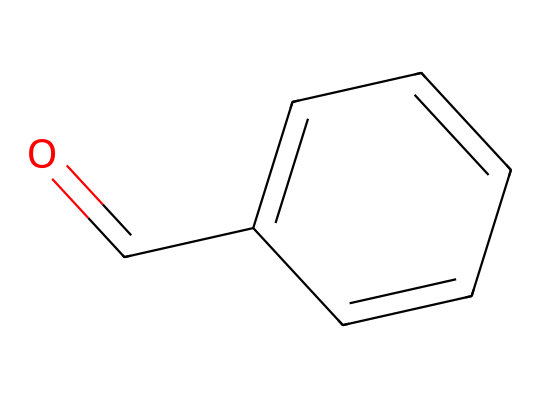What is the main functional group present in this chemical? The chemical structure includes a carbonyl group (C=O) attached to a carbon atom, indicating the presence of an aldehyde functional group in its structure.
Answer: aldehyde How many carbon atoms are in this compound? The visual representation shows a total of 7 carbon atoms, as indicated by the carbon chain and the benzene ring structure.
Answer: 7 What is the molecular formula derived from this structure? From the structure, we can count the atoms as follows: 7 carbon (C), 6 hydrogen (H), and 1 oxygen (O), which gives the molecular formula C7H6O.
Answer: C7H6O What type of ring structure is present in benzaldehyde? The chemical structure consists of a phenyl ring, which is a six-membered carbon ring with alternating double bonds, confirming its aromatic nature.
Answer: benzene What property causes benzaldehyde to be associated with almond flavoring? The structure includes an aromatic ring and a carbonyl group, which contribute to its sweet, nutty aroma characteristic of almonds.
Answer: aroma What is the carbonyl group's location in this molecule? The carbonyl group (C=O) is at the end of the carbon chain, positioning it as the functional group typical of aldehydes.
Answer: terminal In what types of products is benzaldehyde commonly found? Benzaldehyde is often found in flavorings and fragrances, especially in products imitating cherry and almond flavors.
Answer: flavorings 